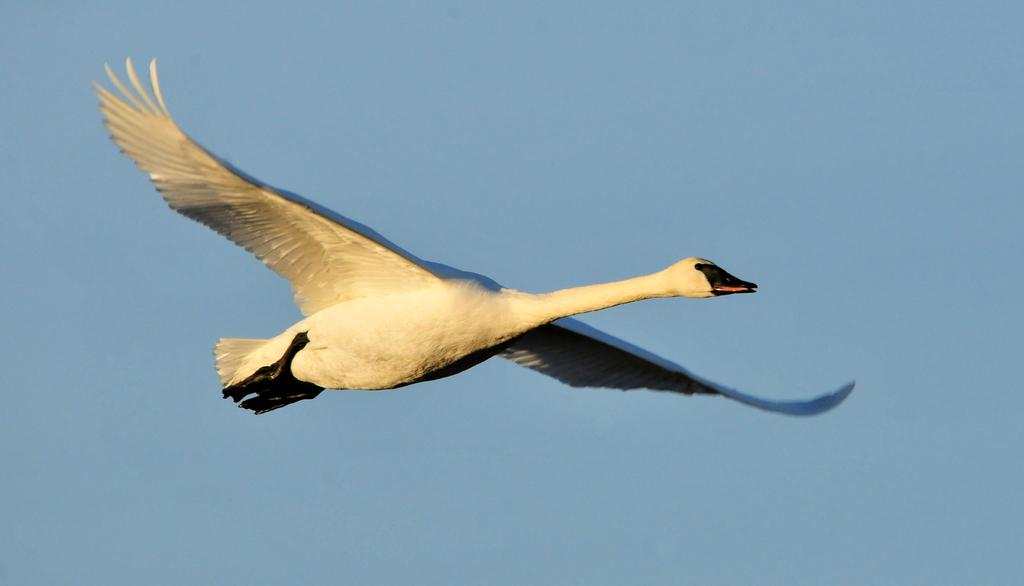What is the main subject of the image? The main subject of the image is a bird flying. Can you describe the appearance of the bird? The bird is white and black in color. What color is the sky in the image? The sky is blue in the image. What type of flesh can be seen hanging from the bird in the image? There is no flesh hanging from the bird in the image; it is a bird flying in the sky. What kind of rock is visible in the image? There is no rock present in the image. 